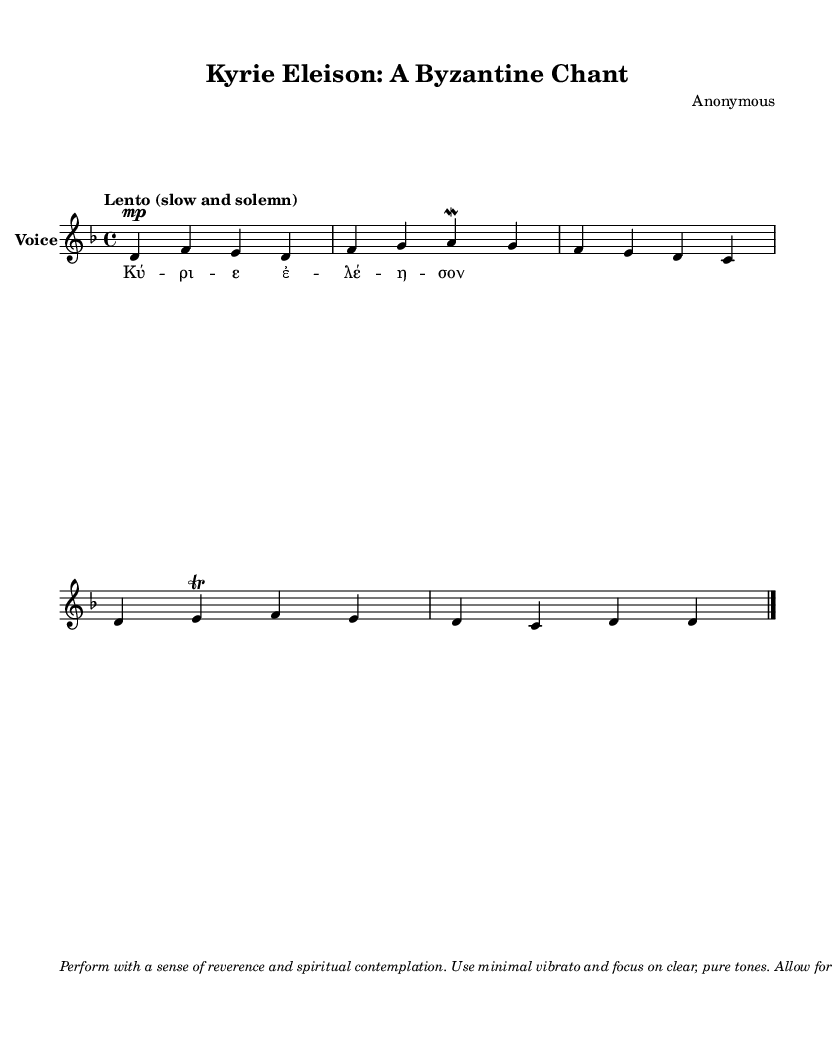What is the key signature of this music? The key signature is indicated at the beginning of the piece, which shows two flats. This corresponds to the key of D minor.
Answer: D minor What is the time signature of this music? The time signature is displayed at the beginning of the piece as 4/4, meaning there are four beats in a measure and the quarter note gets one beat.
Answer: 4/4 What is the tempo indication for this piece? The tempo marking in the music states "Lento (slow and solemn)," suggesting a slow pace for the performance.
Answer: Lento How many measures are in the melody? Counting the measures in the provided melody, there are a total of 5 measures within this chant.
Answer: 5 What is the text of the hymn? The hymn text is indicated in the lyrics section below the melody, which is "Kyrie Eleison" meaning "Lord, have mercy" in Greek.
Answer: Kyrie Eleison What performance instruction is given in the markup? The markup provides specific instructions for performing the piece with a focus on reverence and purity of tone, as well as rhythmic flexibility. The main instruction highlighted is to "perform with a sense of reverence and spiritual contemplation."
Answer: Perform with reverence What does the "mordent" symbol indicate in the music? The "mordent" symbol above the note in the melody notates a specific ornamentation to be performed; in this case, it directs the performer to rapidly alternate between the note and the note above it.
Answer: Ornamentation (mordent) 